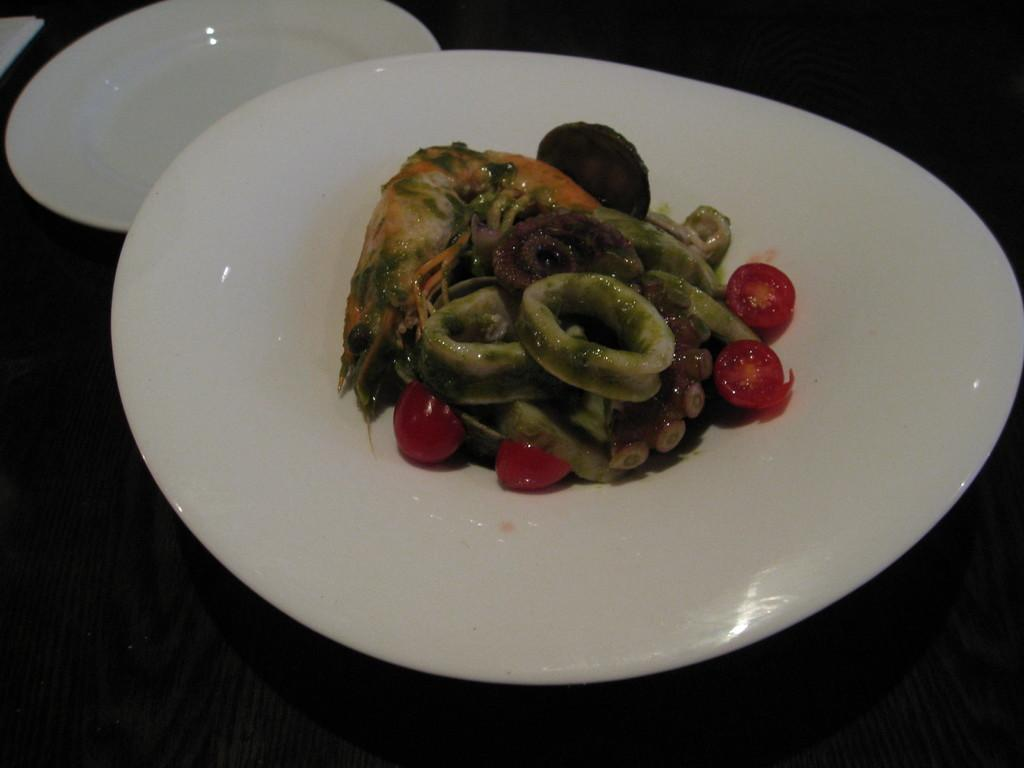What is on the plate that is visible in the image? There is a plate with shrimp and vegetables in the image. Where is the plate located? The plate is on a table. Are there any other plates present in the image? Yes, there is another plate present in the image. What type of liquid is being served in the lunchroom in the image? There is no lunchroom or liquid present in the image; it only features a plate with shrimp and vegetables on a table. Can you tell me how many yaks are visible in the image? There are no yaks present in the image. 